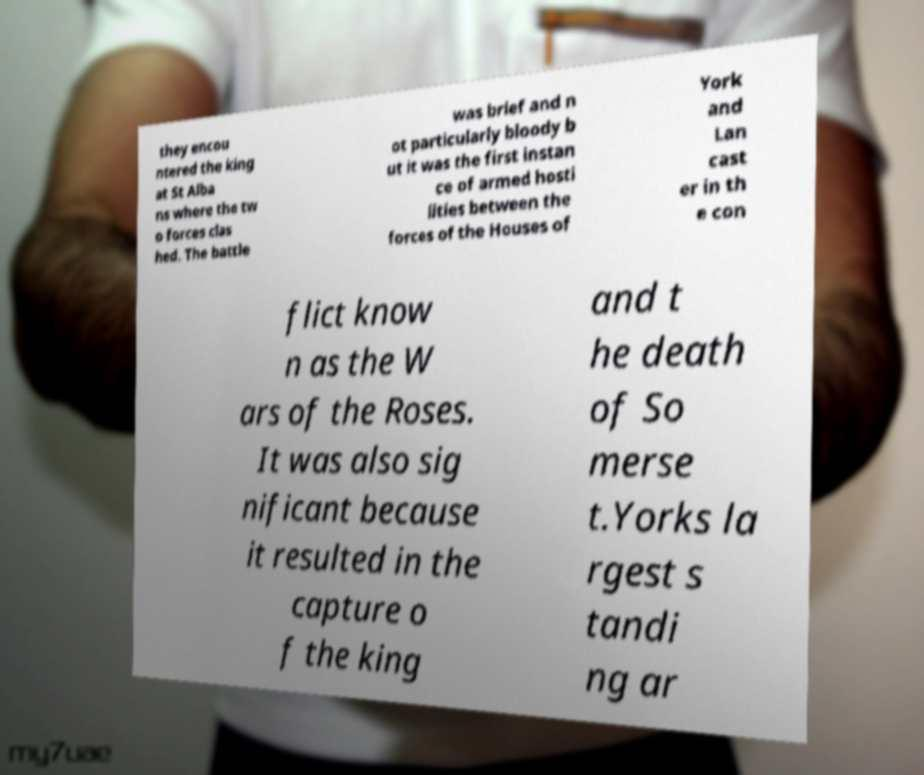What messages or text are displayed in this image? I need them in a readable, typed format. they encou ntered the king at St Alba ns where the tw o forces clas hed. The battle was brief and n ot particularly bloody b ut it was the first instan ce of armed hosti lities between the forces of the Houses of York and Lan cast er in th e con flict know n as the W ars of the Roses. It was also sig nificant because it resulted in the capture o f the king and t he death of So merse t.Yorks la rgest s tandi ng ar 